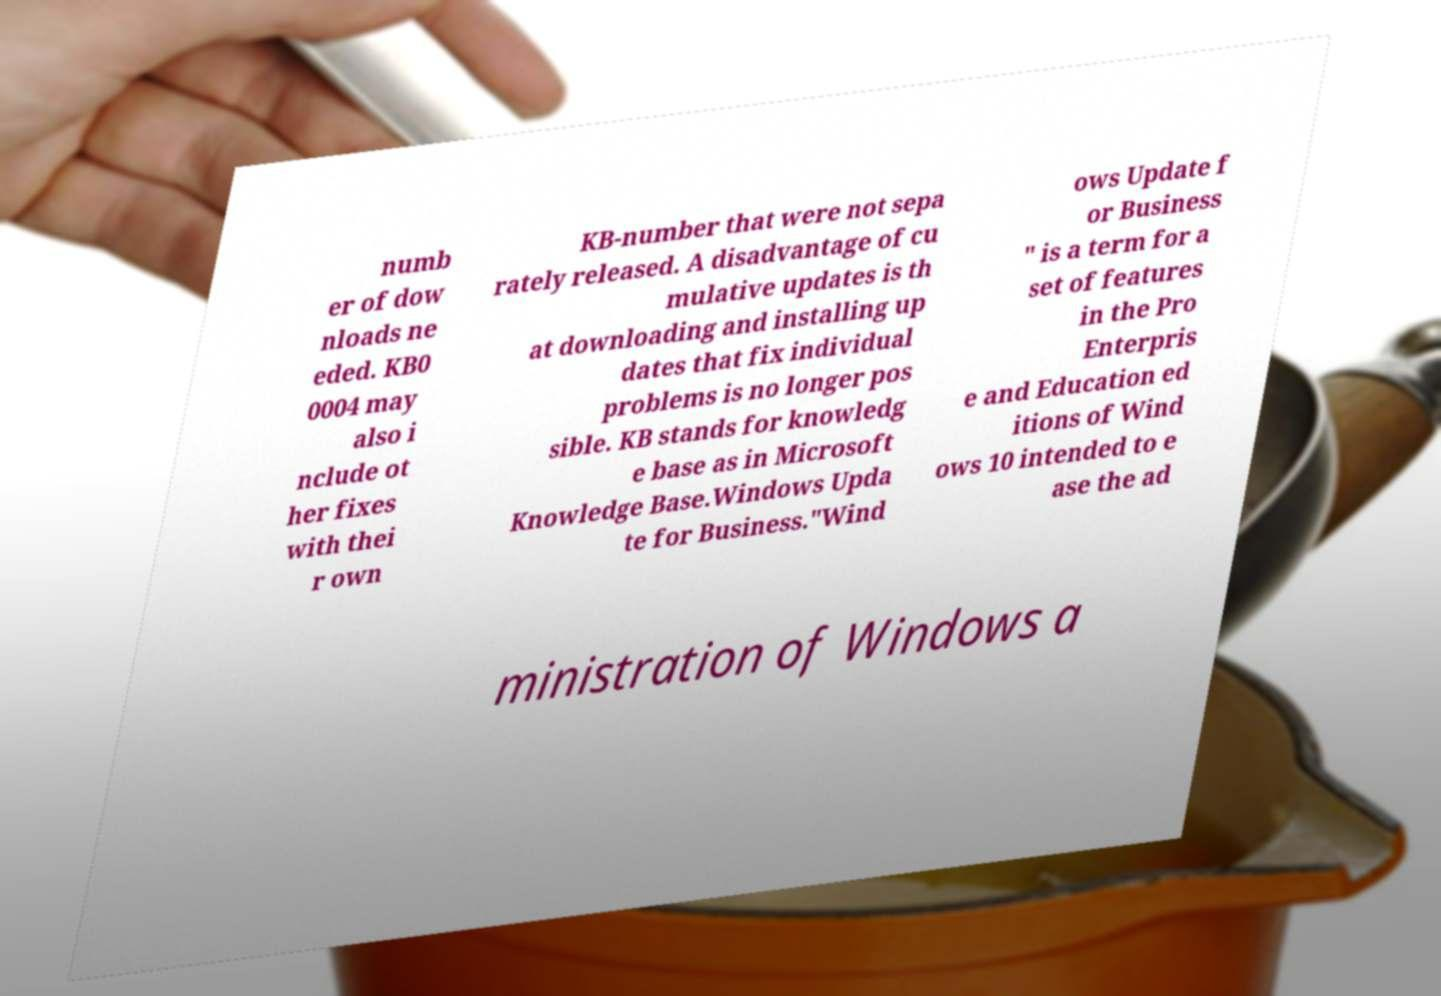I need the written content from this picture converted into text. Can you do that? numb er of dow nloads ne eded. KB0 0004 may also i nclude ot her fixes with thei r own KB-number that were not sepa rately released. A disadvantage of cu mulative updates is th at downloading and installing up dates that fix individual problems is no longer pos sible. KB stands for knowledg e base as in Microsoft Knowledge Base.Windows Upda te for Business."Wind ows Update f or Business " is a term for a set of features in the Pro Enterpris e and Education ed itions of Wind ows 10 intended to e ase the ad ministration of Windows a 